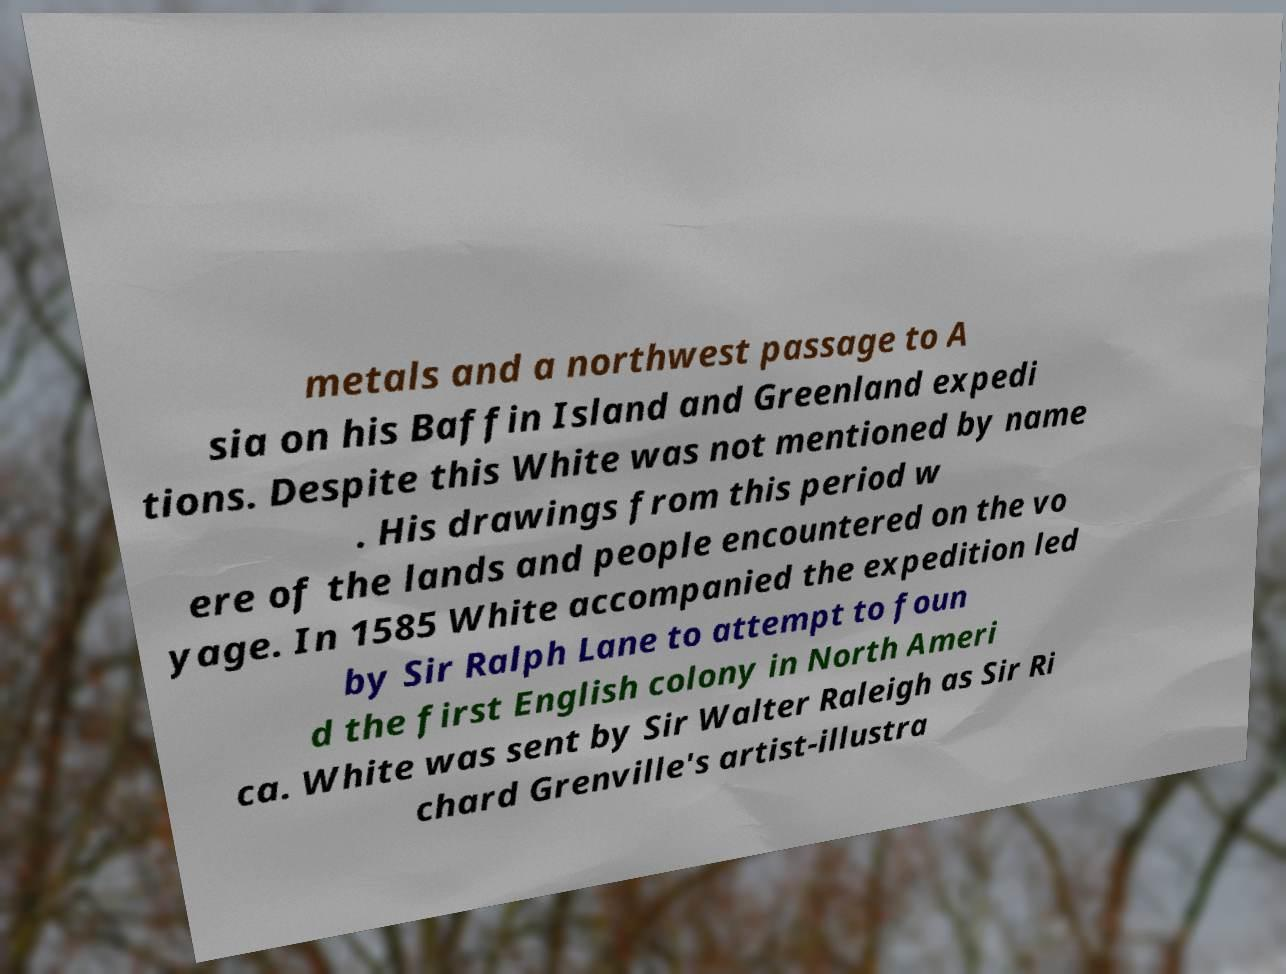For documentation purposes, I need the text within this image transcribed. Could you provide that? metals and a northwest passage to A sia on his Baffin Island and Greenland expedi tions. Despite this White was not mentioned by name . His drawings from this period w ere of the lands and people encountered on the vo yage. In 1585 White accompanied the expedition led by Sir Ralph Lane to attempt to foun d the first English colony in North Ameri ca. White was sent by Sir Walter Raleigh as Sir Ri chard Grenville's artist-illustra 